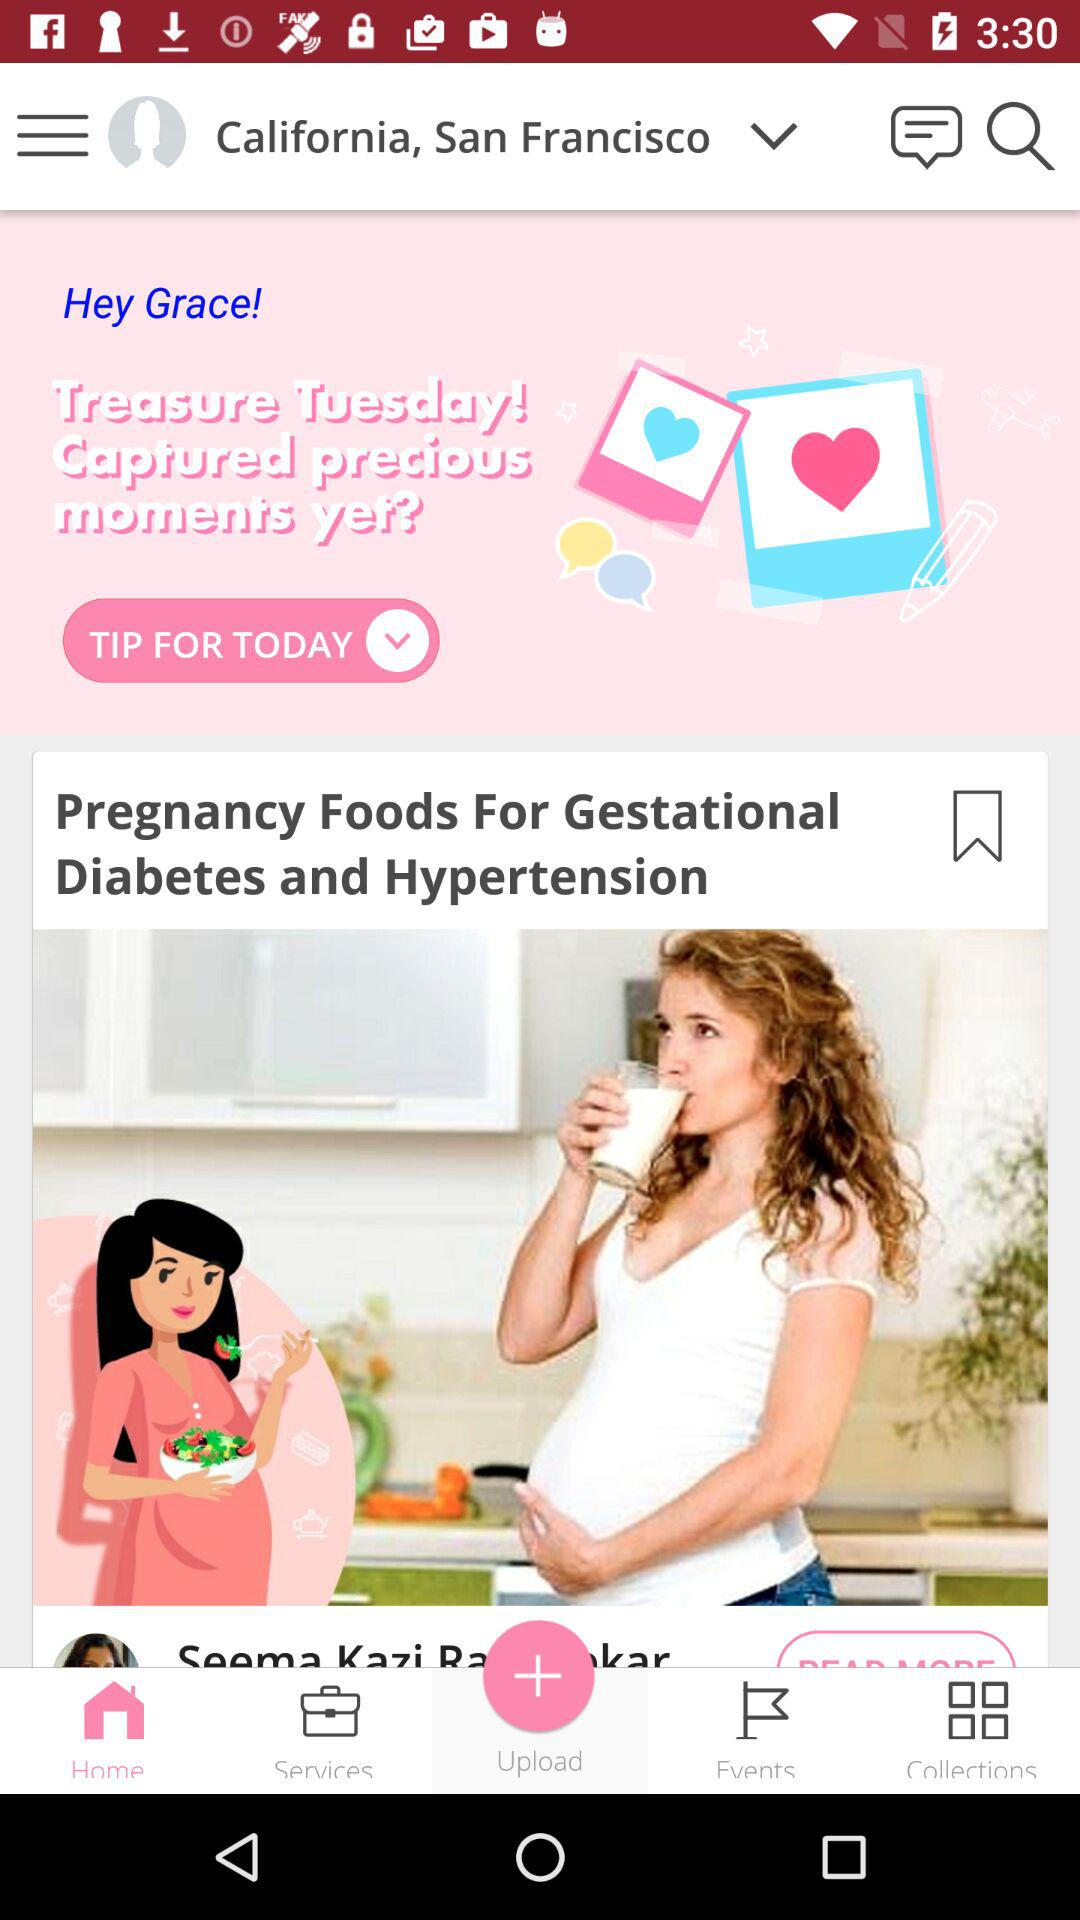What is the name of the user? The name of the user is Grace. 